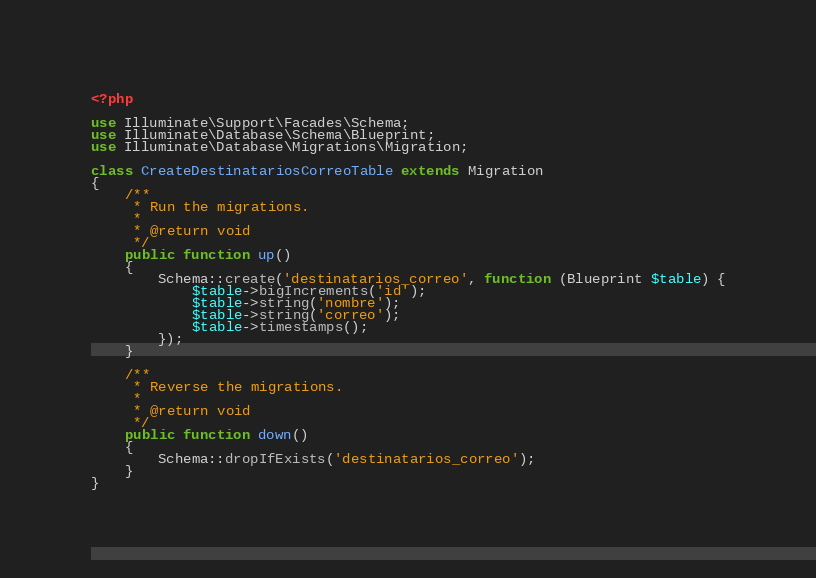Convert code to text. <code><loc_0><loc_0><loc_500><loc_500><_PHP_><?php

use Illuminate\Support\Facades\Schema;
use Illuminate\Database\Schema\Blueprint;
use Illuminate\Database\Migrations\Migration;

class CreateDestinatariosCorreoTable extends Migration
{
    /**
     * Run the migrations.
     *
     * @return void
     */
    public function up()
    {
        Schema::create('destinatarios_correo', function (Blueprint $table) {
            $table->bigIncrements('id');
            $table->string('nombre');
            $table->string('correo');
            $table->timestamps();
        });
    }

    /**
     * Reverse the migrations.
     *
     * @return void
     */
    public function down()
    {
        Schema::dropIfExists('destinatarios_correo');
    }
}
</code> 